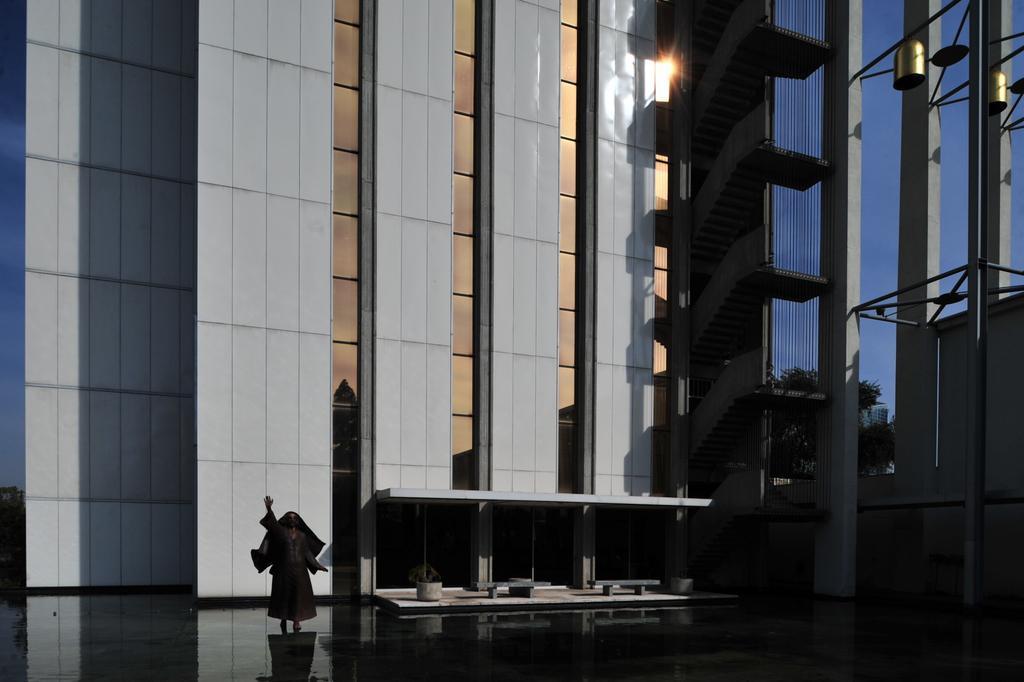Could you give a brief overview of what you see in this image? In this image I can see the black colored floor, a black colored statue of a person and the building which is grey in color. In the background I can see few trees, the sky, few pillars and two gold colored objects. 